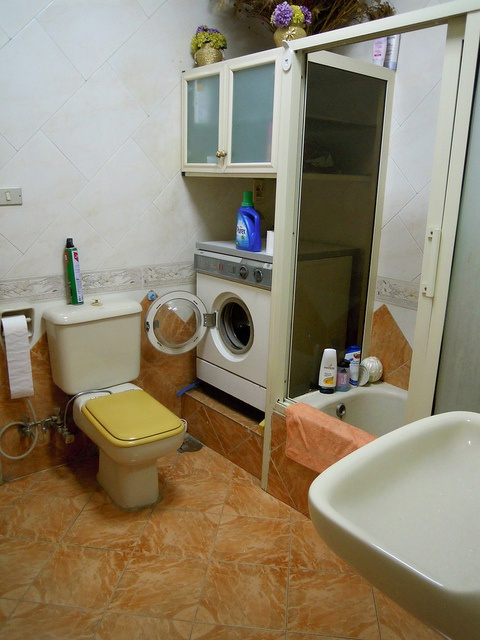Describe the objects in this image and their specific colors. I can see sink in lightgray, darkgray, and olive tones, toilet in lightgray, tan, olive, darkgray, and gray tones, potted plant in lightgray, black, olive, and gray tones, bottle in lightgray, darkblue, blue, and black tones, and potted plant in lightgray, olive, and gray tones in this image. 